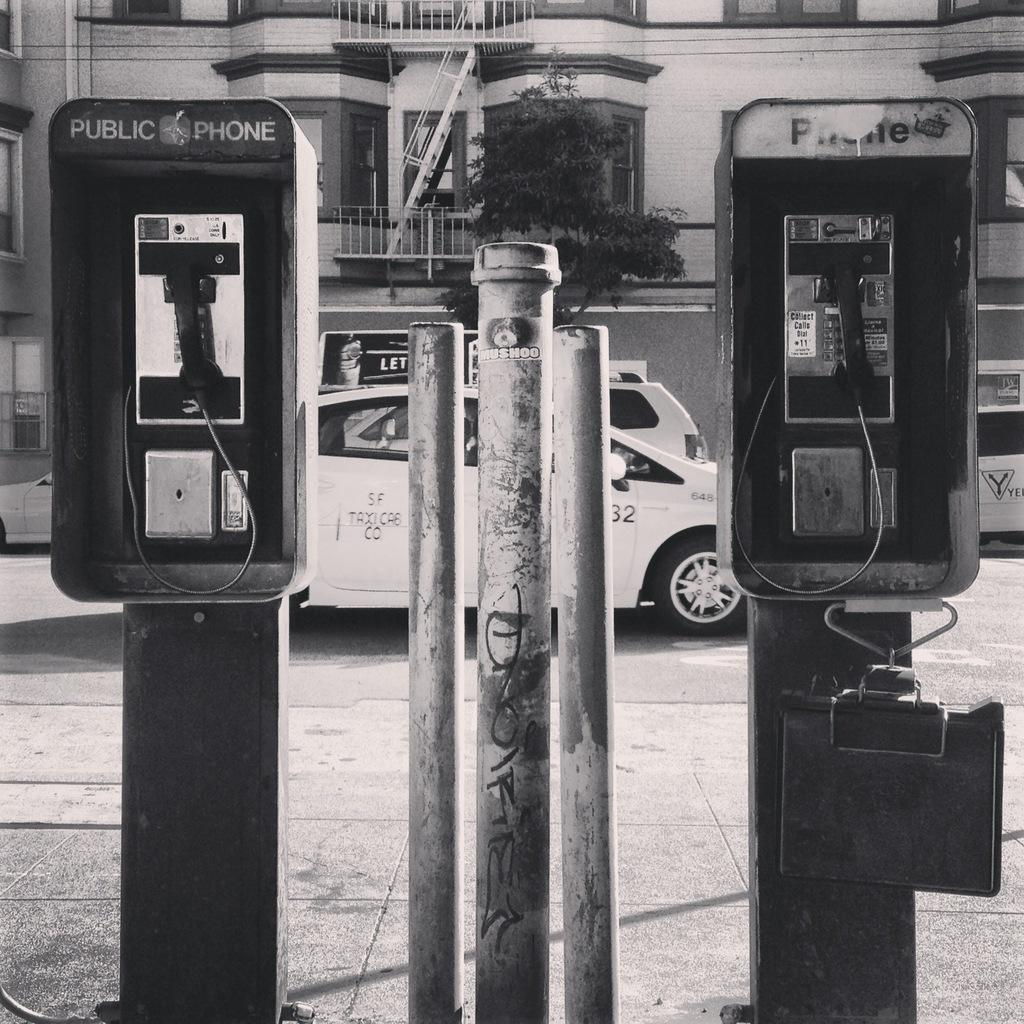<image>
Give a short and clear explanation of the subsequent image. The pay phones in the black and white photo have "public phone" on them 